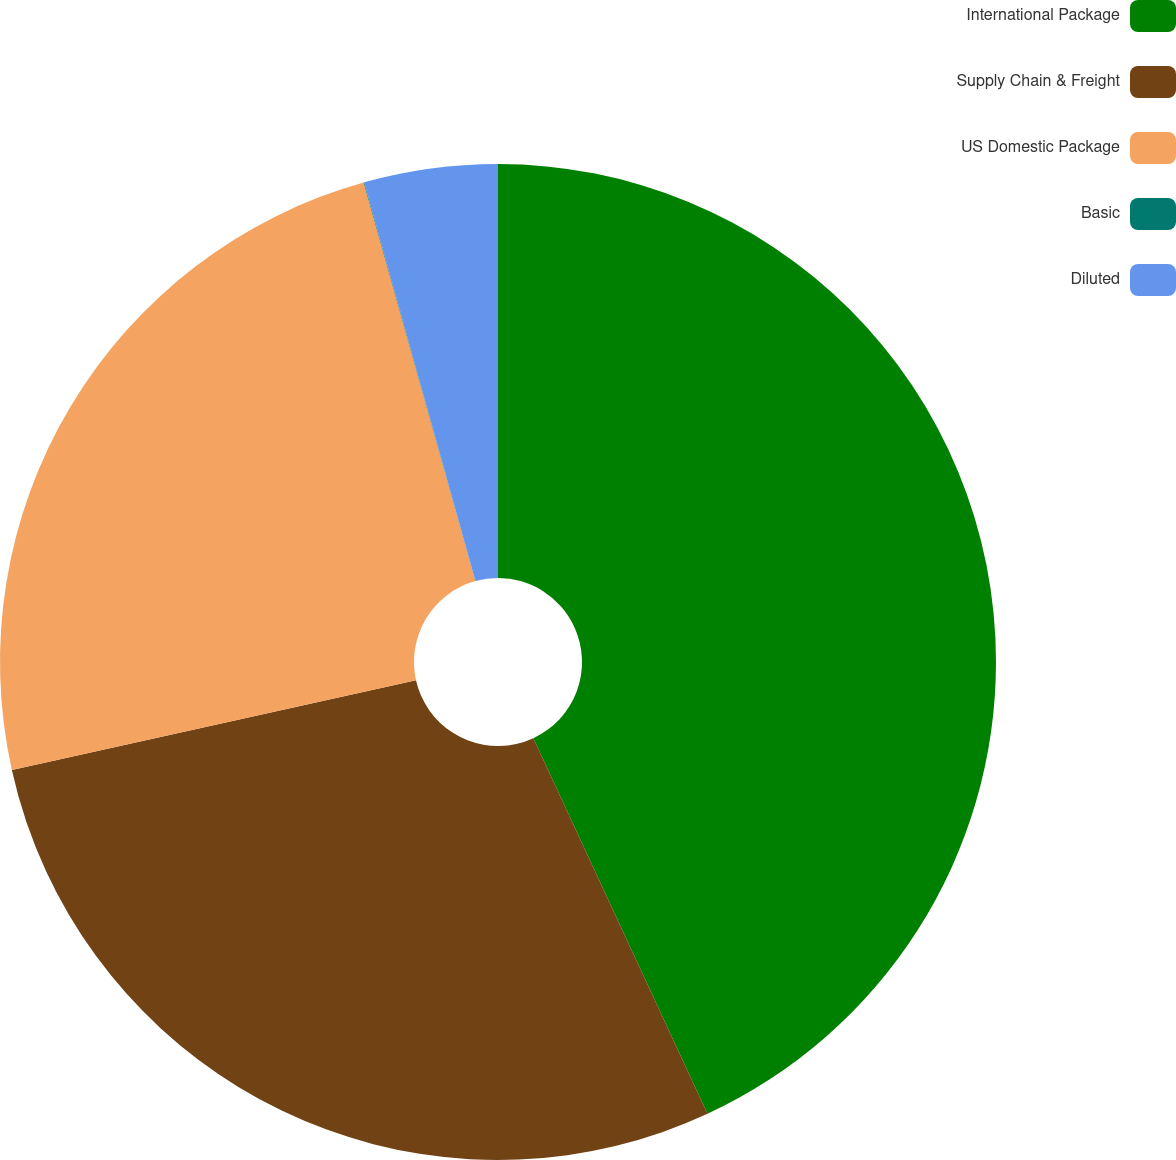Convert chart. <chart><loc_0><loc_0><loc_500><loc_500><pie_chart><fcel>International Package<fcel>Supply Chain & Freight<fcel>US Domestic Package<fcel>Basic<fcel>Diluted<nl><fcel>43.09%<fcel>28.43%<fcel>24.13%<fcel>0.02%<fcel>4.33%<nl></chart> 